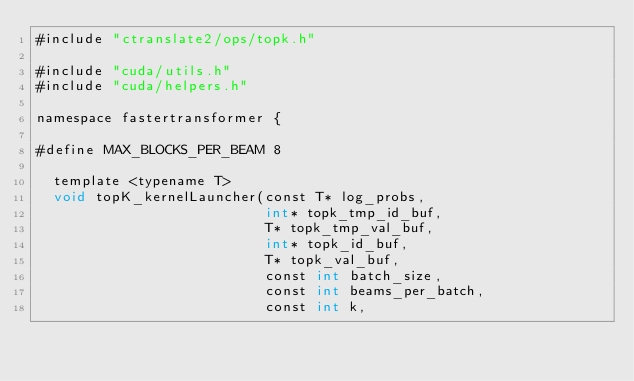Convert code to text. <code><loc_0><loc_0><loc_500><loc_500><_Cuda_>#include "ctranslate2/ops/topk.h"

#include "cuda/utils.h"
#include "cuda/helpers.h"

namespace fastertransformer {

#define MAX_BLOCKS_PER_BEAM 8

  template <typename T>
  void topK_kernelLauncher(const T* log_probs,
                           int* topk_tmp_id_buf,
                           T* topk_tmp_val_buf,
                           int* topk_id_buf,
                           T* topk_val_buf,
                           const int batch_size,
                           const int beams_per_batch,
                           const int k,</code> 